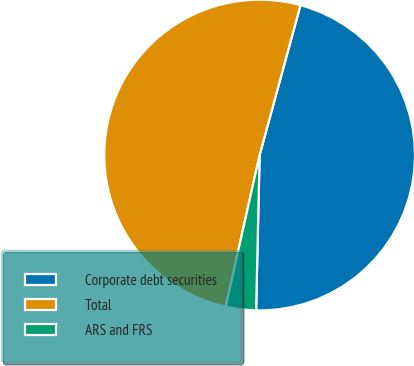Convert chart to OTSL. <chart><loc_0><loc_0><loc_500><loc_500><pie_chart><fcel>Corporate debt securities<fcel>Total<fcel>ARS and FRS<nl><fcel>46.12%<fcel>50.73%<fcel>3.14%<nl></chart> 